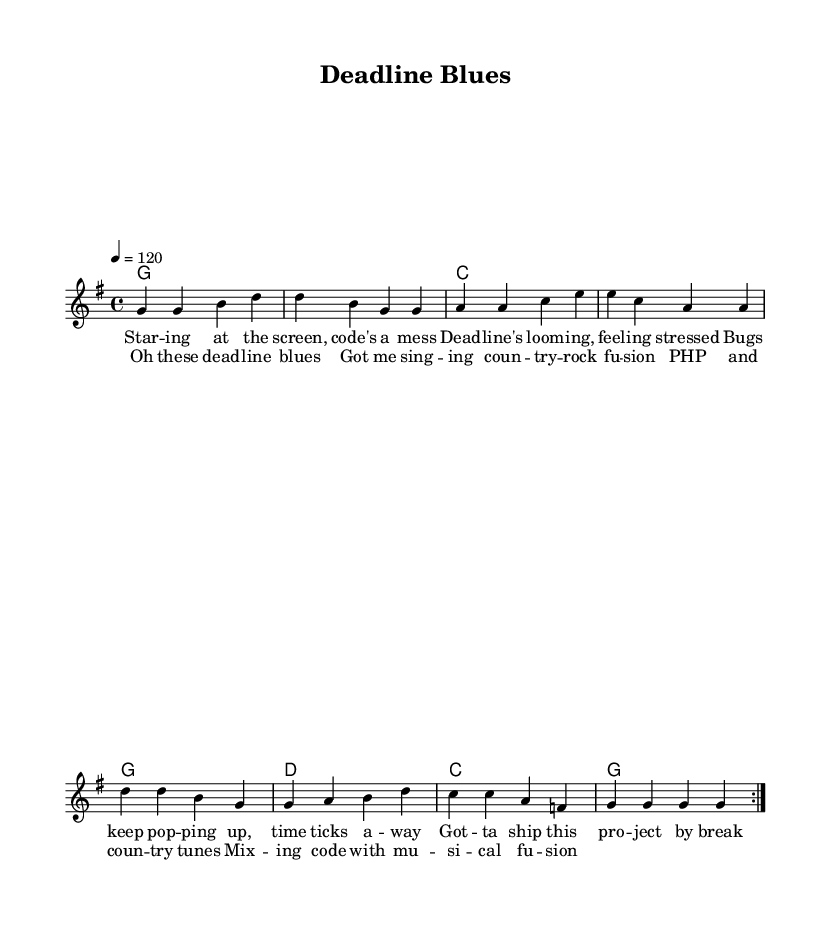What is the key signature of this music? The key signature indicates G major, which has one sharp (F#). This is evident in the global section where the key is specified.
Answer: G major What is the time signature of this music? The time signature is indicated in the global section as 4/4, meaning there are four beats in each measure and the quarter note gets one beat.
Answer: 4/4 What is the tempo of this music? The tempo is set at 120 beats per minute in the global section. This gives a moderate pace to the music.
Answer: 120 How many measures are there in the melody? The melody section consists of a repeated sequence, with each repeat having 8 measures, so the total number of measures is 16.
Answer: 16 What is the primary theme of the lyrics? The lyrics discuss feelings associated with project deadlines and the stress that comes from coding and troubleshooting.
Answer: Deadlines and stress What type of music fusion is represented in this song? The song combines elements of country and rock, as indicated in the chorus with the phrase "country-rock fusion."
Answer: Country-rock fusion How is the structure of the song organized? The song is organized with the first verse followed by the chorus, which is a common structure in many songs, allowing for storytelling followed by a repeated refrain.
Answer: Verse and chorus structure 